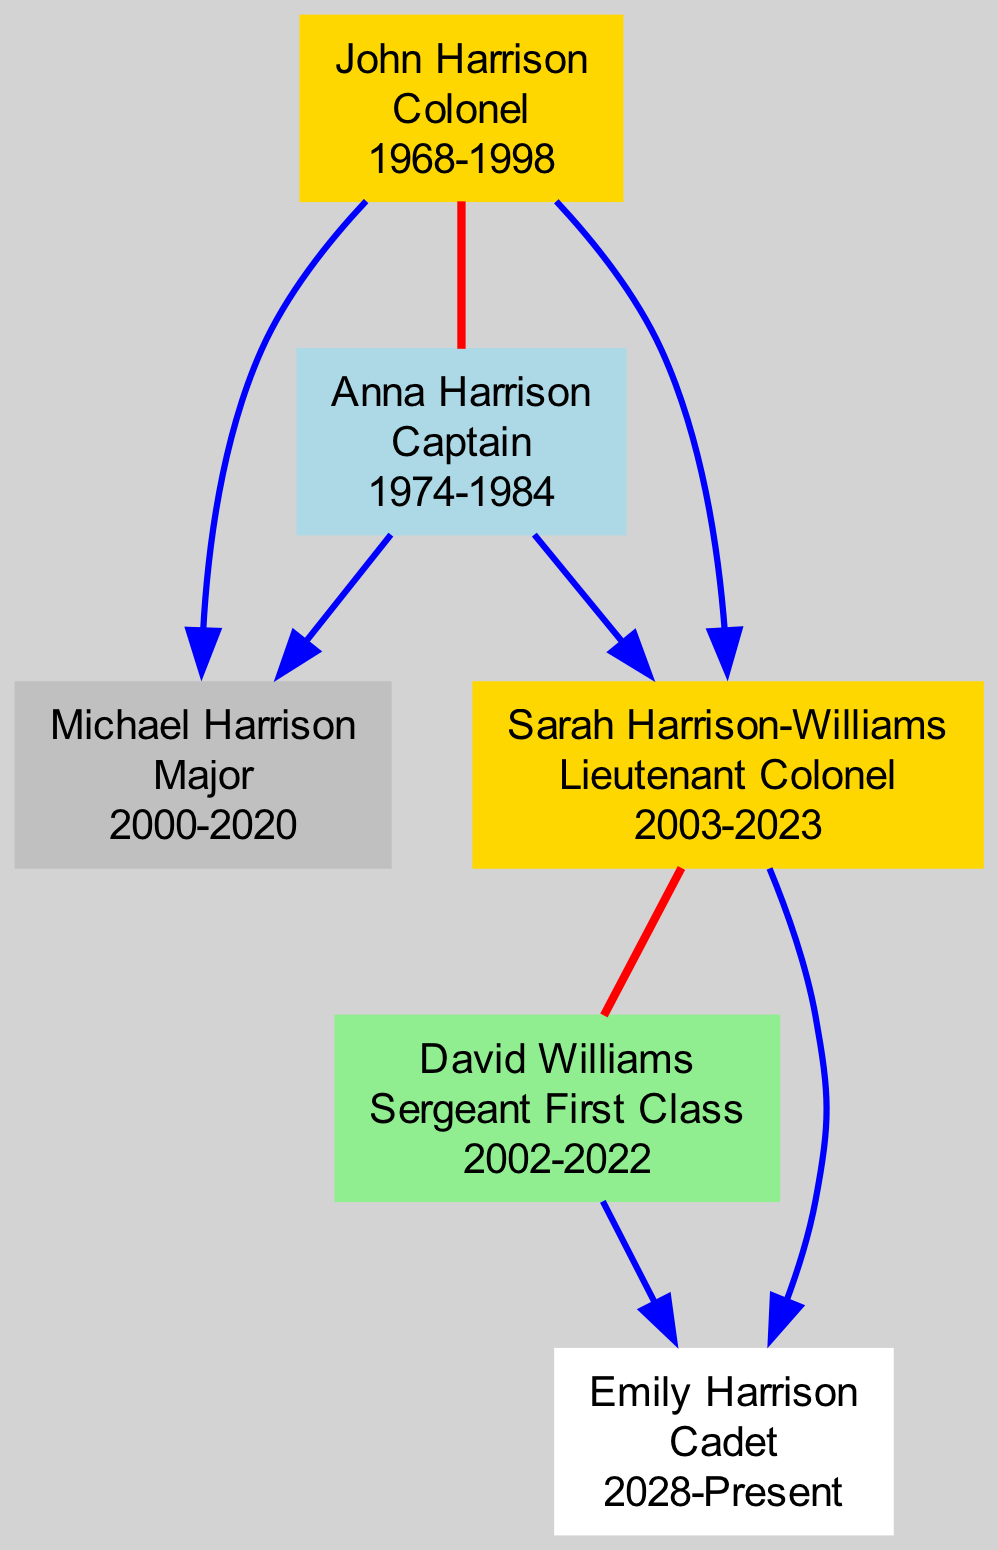What is the highest military rank achieved by John Harrison? According to the diagram, John Harrison's highest rank is listed as "Colonel."
Answer: Colonel How many members in the Harrison family are military personnel? The diagram shows six family members, all of whom have military involvement indicated by their join and discharge years.
Answer: 6 Who is the spouse of Sarah Harrison-Williams? By examining the relationships in the diagram, David Williams is identified as the spouse of Sarah Harrison-Williams.
Answer: David Williams Which family member has the lowest rank? The diagram indicates that Emily Harrison holds the rank of "Cadet," which is the lowest among the ranks displayed.
Answer: Cadet What year did Michael Harrison join the military? The join year associated with Michael Harrison in the diagram is noted as 2000.
Answer: 2000 How many children do John and Anna Harrison have? The diagram shows that John and Anna Harrison are parents to two children: Michael Harrison and Sarah Harrison-Williams.
Answer: 2 Who achieved the rank of Lieutenant Colonel? The diagram specifies that Sarah Harrison-Williams achieved the rank of "Lieutenant Colonel."
Answer: Sarah Harrison-Williams What relationship do Emily Harrison and John Harrison share? Following the lines of relationships, Emily Harrison is the granddaughter of John Harrison, making the relationship one of grandparent to grandchild.
Answer: Granddaughter Which member's military career is currently ongoing? The diagram indicates that Emily Harrison has a join year of 2028 and does not have a discharge year, signifying her career is not completed yet.
Answer: Emily Harrison What is the highest rank achieved by Anna Harrison? The highest rank reached by Anna Harrison is identified as "Captain" in the diagram.
Answer: Captain 